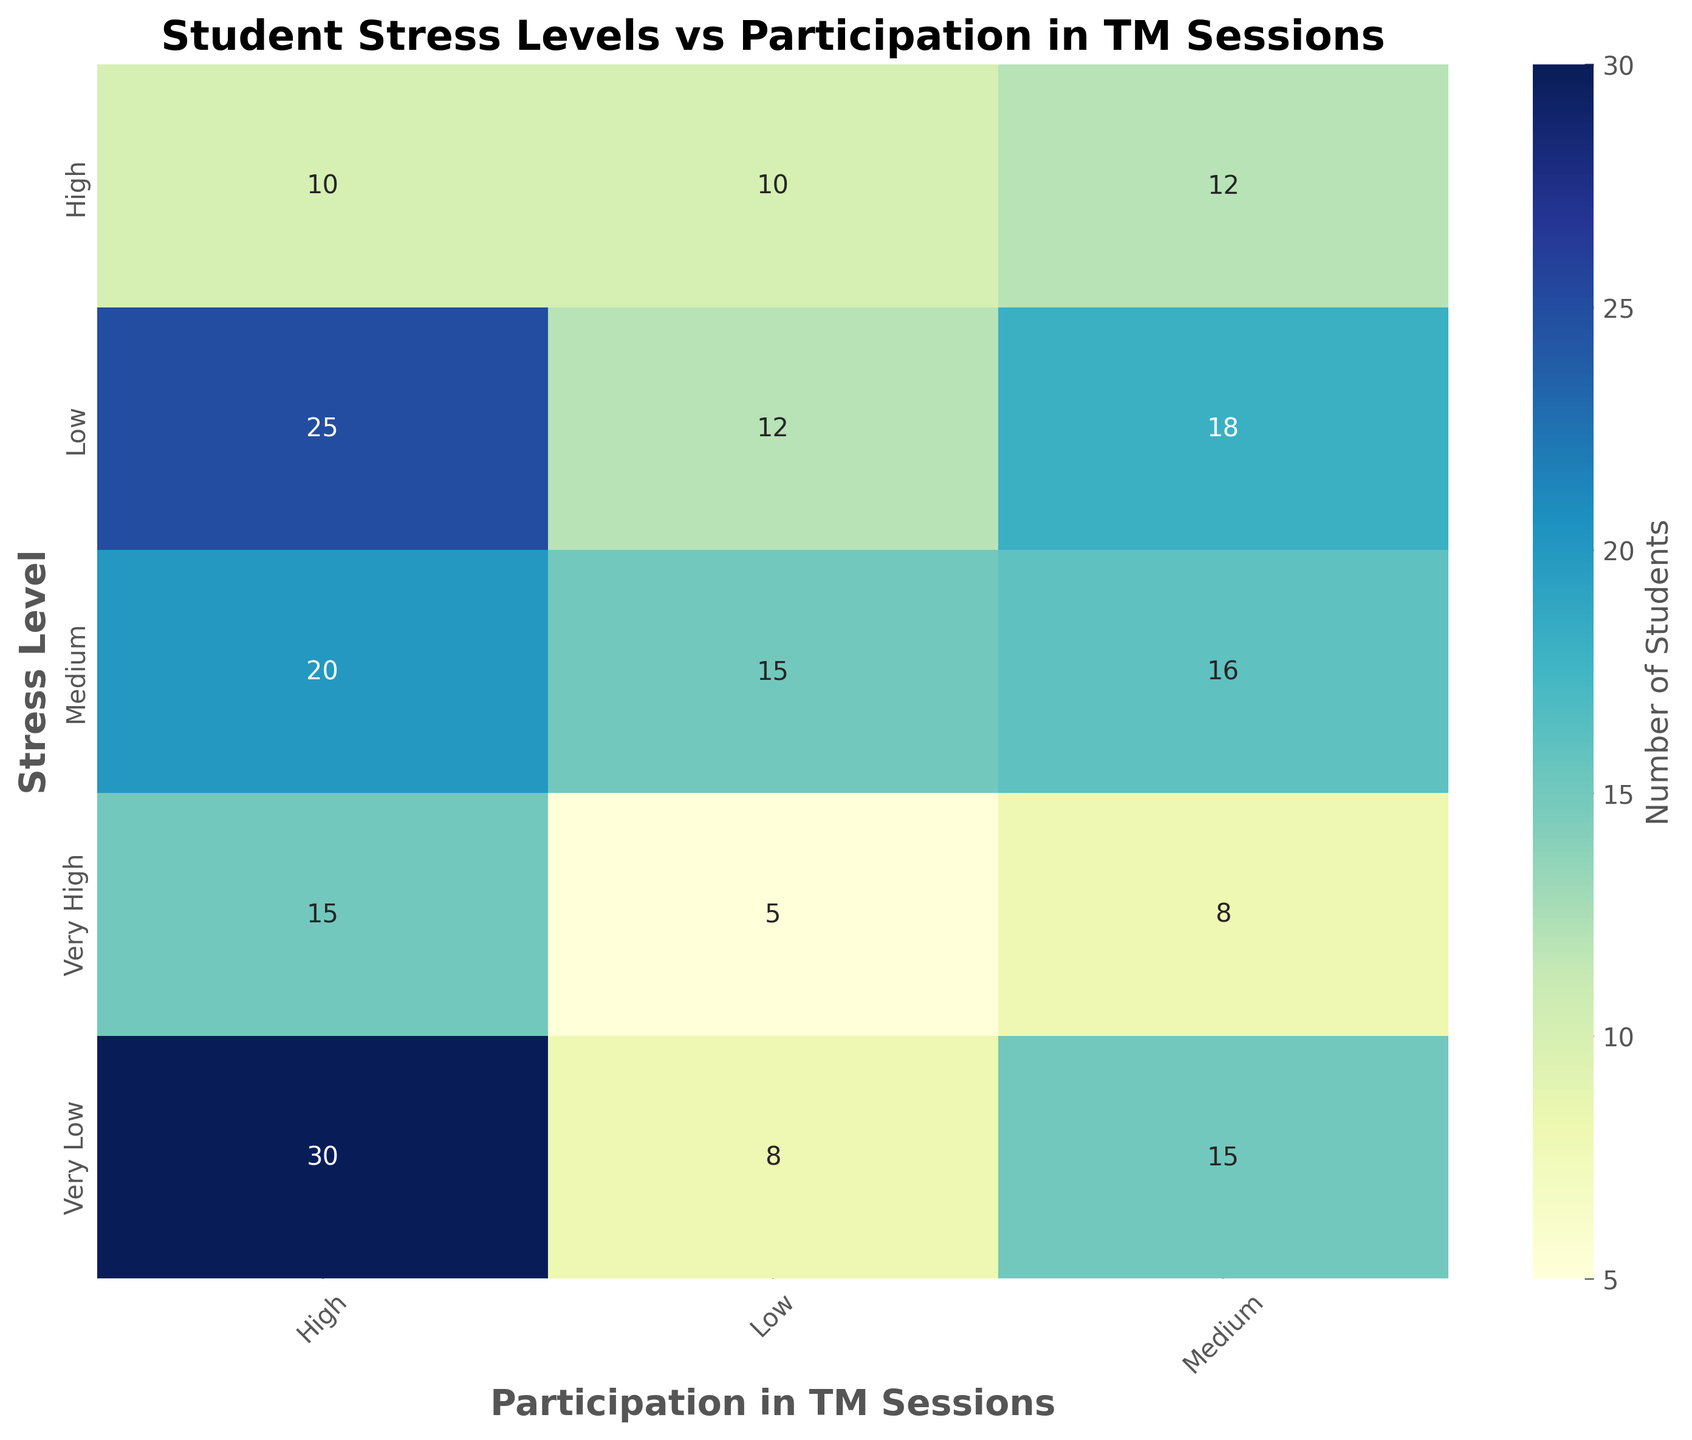What is the total number of students with Medium stress levels? To find the total number of students with Medium stress levels, sum the numbers associated with Medium stress level across all participation levels (Low, Medium, High). So, 15 (Low) + 16 (Medium) + 20 (High) gives us 51.
Answer: 51 Which participation level has the highest number of students with Very Low stress levels? From the heatmap, look at the row corresponding to the Very Low stress level. The values are 8 (Low), 15 (Medium), and 30 (High). The highest value is 30, so the highest number of students with Very Low stress levels participates at the High level.
Answer: High Is there a trend between participation in TM sessions and stress levels? To identify a trend, observe the heatmap for patterns in the values of students' numbers as participation levels increase. There seems to be a trend that as participation in TM sessions increases from Low to High, the number of students with lower stress levels increases. Specifically, students with Very Low stress levels increase from 8 (Low) to 30 (High), while students with Very High stress levels decrease from 5 (Low) to 15 (High).
Answer: Yes, increased participation correlates with lower stress levels How many more students with Low stress levels participate at a High level compared to a Low level? To find the difference, subtract the number of students with Low stress levels participating at the Low level (12) from those participating at the High level (25). So, 25 - 12 equals 13.
Answer: 13 Which stress level has the least number of students participating at the Medium level? Look at the Medium column in the heatmap and find the minimum number. The values are 8 (Very High), 12 (High), 16 (Medium), 18 (Low), and 15 (Very Low). The least number of students participating at the Medium level is 8, corresponding to the Very High stress level.
Answer: Very High Compare the number of students with High stress levels participating at High and Medium levels. Which is greater and by how much? From the heatmap, there are 10 students with High stress levels participating at both High and Medium levels. So, the numbers are equal.
Answer: Numbers are equal, no difference What is the total number of students participating at the High level? To find the total number of students participating at the High level, sum the numbers associated with the High participation level across all stress levels (Very High, High, Medium, Low, Very Low). So, 15 (Very High) + 10 (High) + 20 (Medium) + 25 (Low) + 30 (Very Low) gives us 100.
Answer: 100 